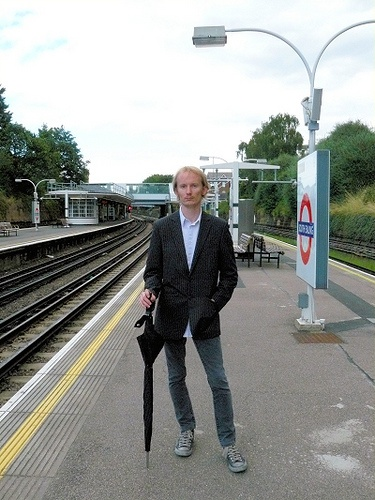Describe the objects in this image and their specific colors. I can see people in white, black, gray, darkgray, and purple tones, umbrella in white, black, gray, and darkgray tones, bench in white, black, gray, and darkgray tones, bench in white, black, gray, darkgray, and lightgray tones, and bench in white, gray, darkgray, and black tones in this image. 